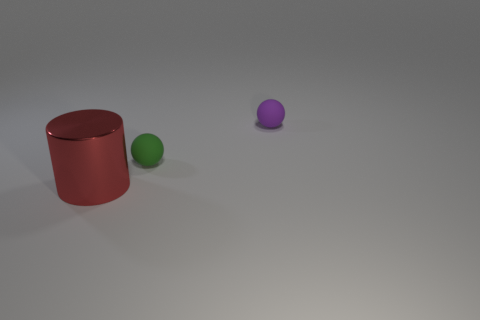What number of things are both on the left side of the purple matte object and on the right side of the red thing?
Offer a very short reply. 1. What number of metallic things are either green balls or cyan spheres?
Provide a short and direct response. 0. There is a small thing that is right of the tiny matte object that is on the left side of the purple sphere; what is its material?
Offer a very short reply. Rubber. What is the shape of the matte object that is the same size as the purple matte ball?
Ensure brevity in your answer.  Sphere. Is the number of large metal objects less than the number of big purple rubber cylinders?
Offer a very short reply. No. There is a rubber ball to the left of the purple sphere; are there any big red shiny cylinders that are behind it?
Keep it short and to the point. No. What is the shape of the tiny thing that is made of the same material as the green ball?
Offer a very short reply. Sphere. Is there anything else of the same color as the large metal object?
Your answer should be very brief. No. There is a small green object that is the same shape as the tiny purple matte object; what is it made of?
Provide a succinct answer. Rubber. What number of other objects are the same size as the red metal cylinder?
Offer a very short reply. 0. 